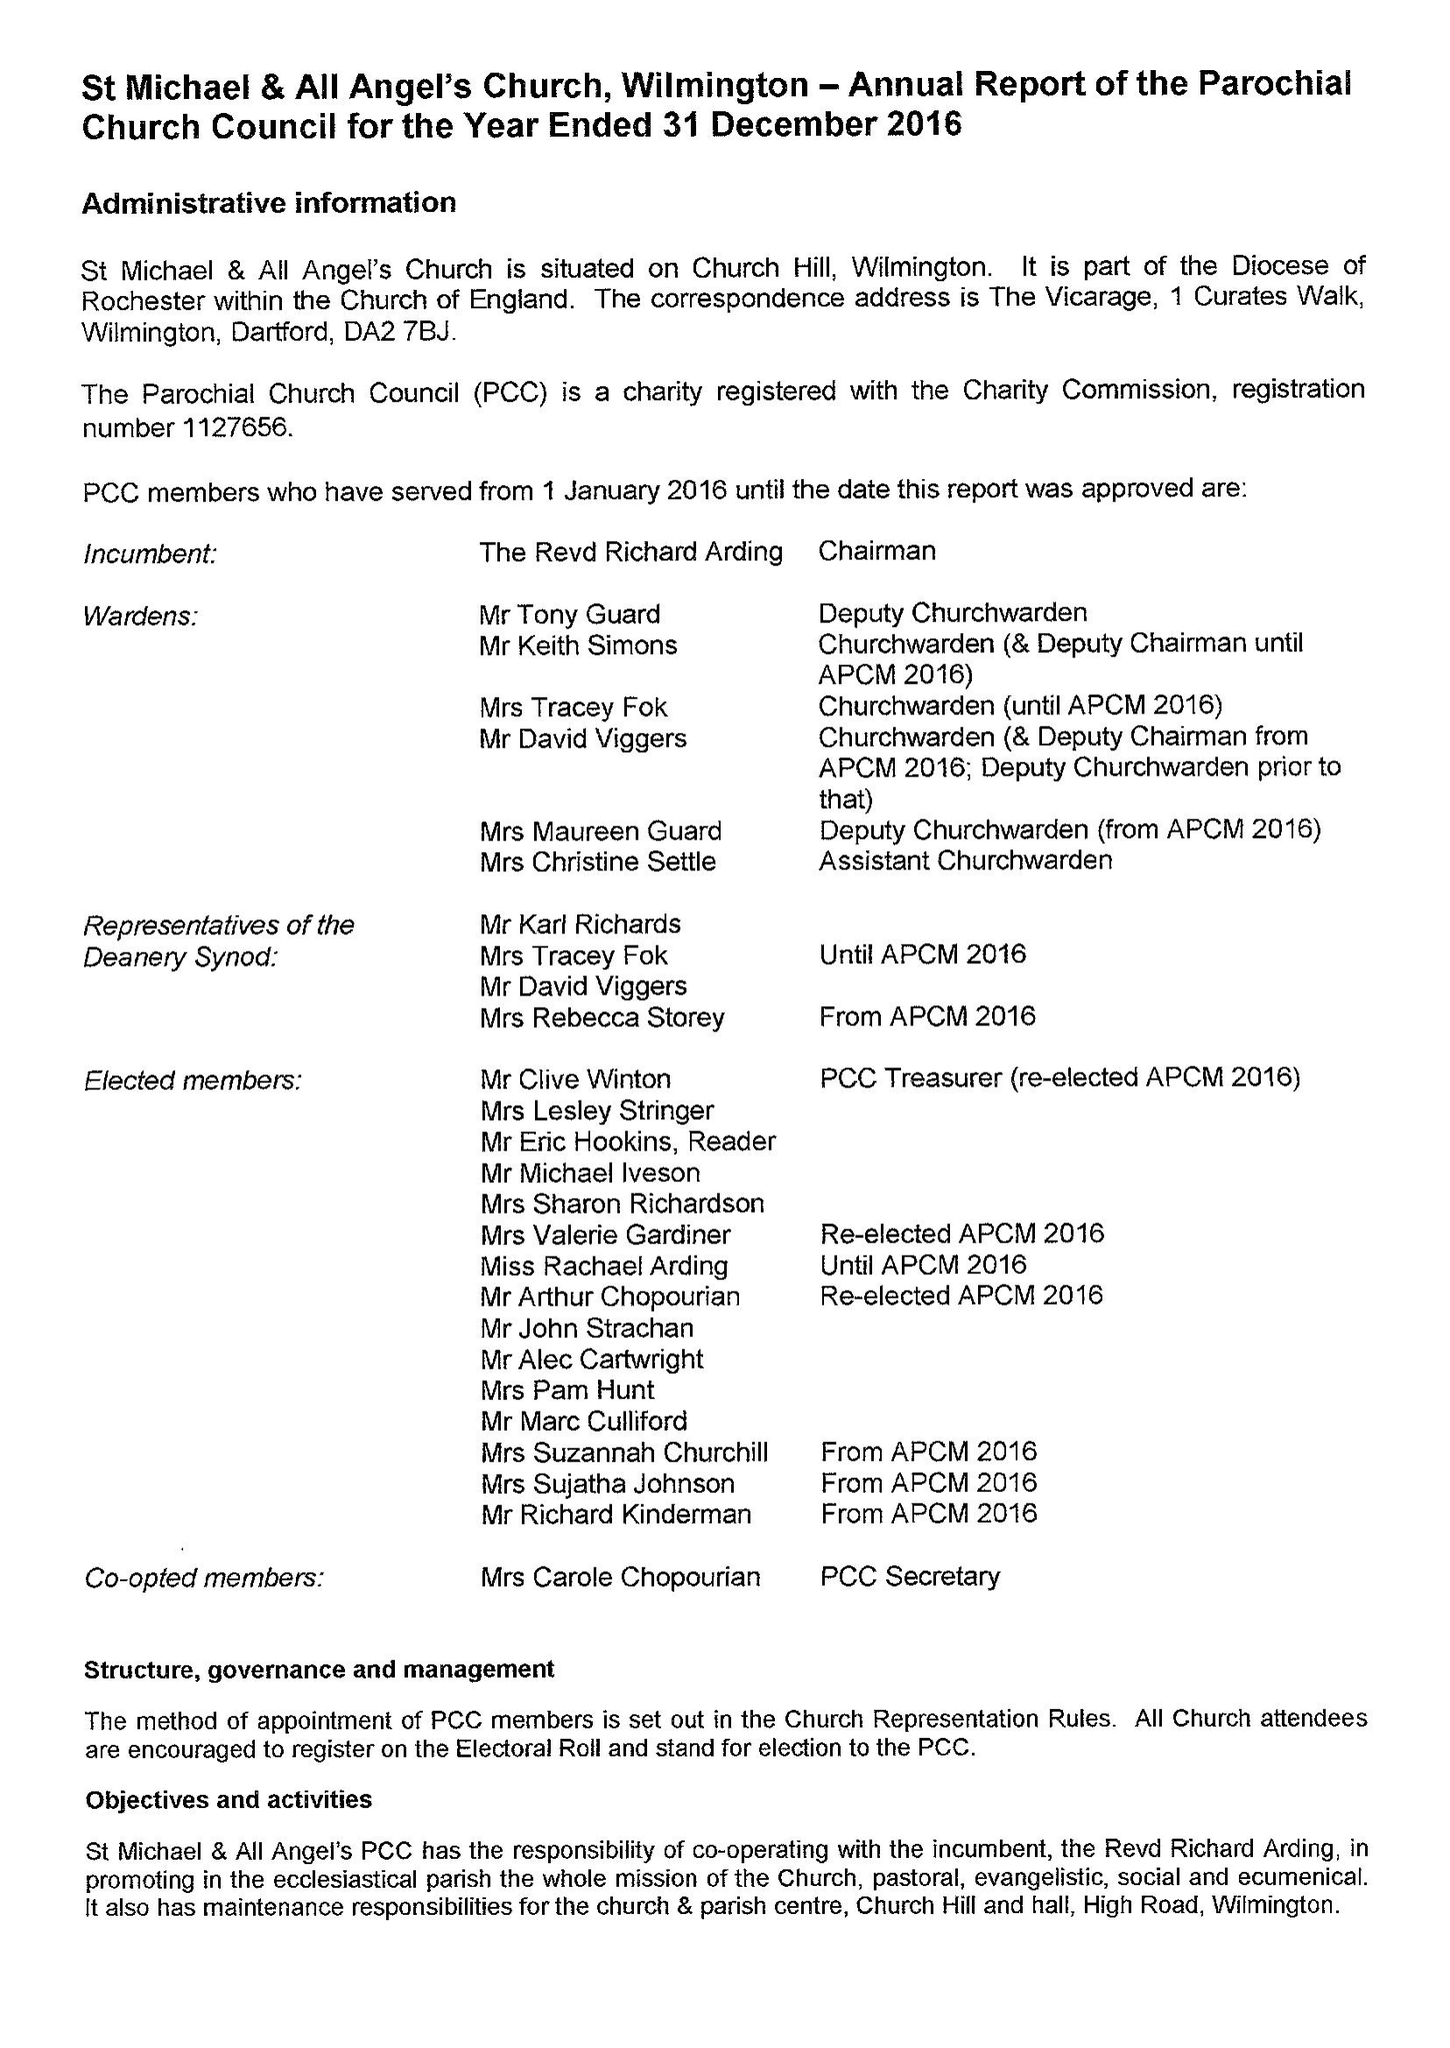What is the value for the address__street_line?
Answer the question using a single word or phrase. 2 HIGH ROAD 